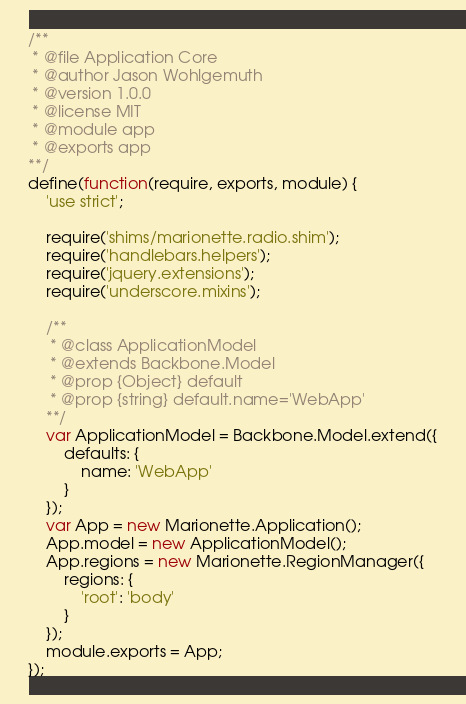<code> <loc_0><loc_0><loc_500><loc_500><_JavaScript_>/**
 * @file Application Core
 * @author Jason Wohlgemuth
 * @version 1.0.0
 * @license MIT
 * @module app
 * @exports app
**/
define(function(require, exports, module) {
    'use strict';

    require('shims/marionette.radio.shim');
    require('handlebars.helpers');
    require('jquery.extensions');
    require('underscore.mixins');

    /**
     * @class ApplicationModel
     * @extends Backbone.Model
     * @prop {Object} default
     * @prop {string} default.name='WebApp'
    **/
    var ApplicationModel = Backbone.Model.extend({
        defaults: {
            name: 'WebApp'
        }
    });
    var App = new Marionette.Application();
    App.model = new ApplicationModel();
    App.regions = new Marionette.RegionManager({
        regions: {
            'root': 'body'
        }
    });
    module.exports = App;
});</code> 